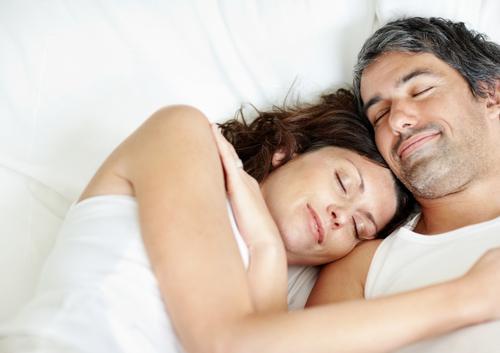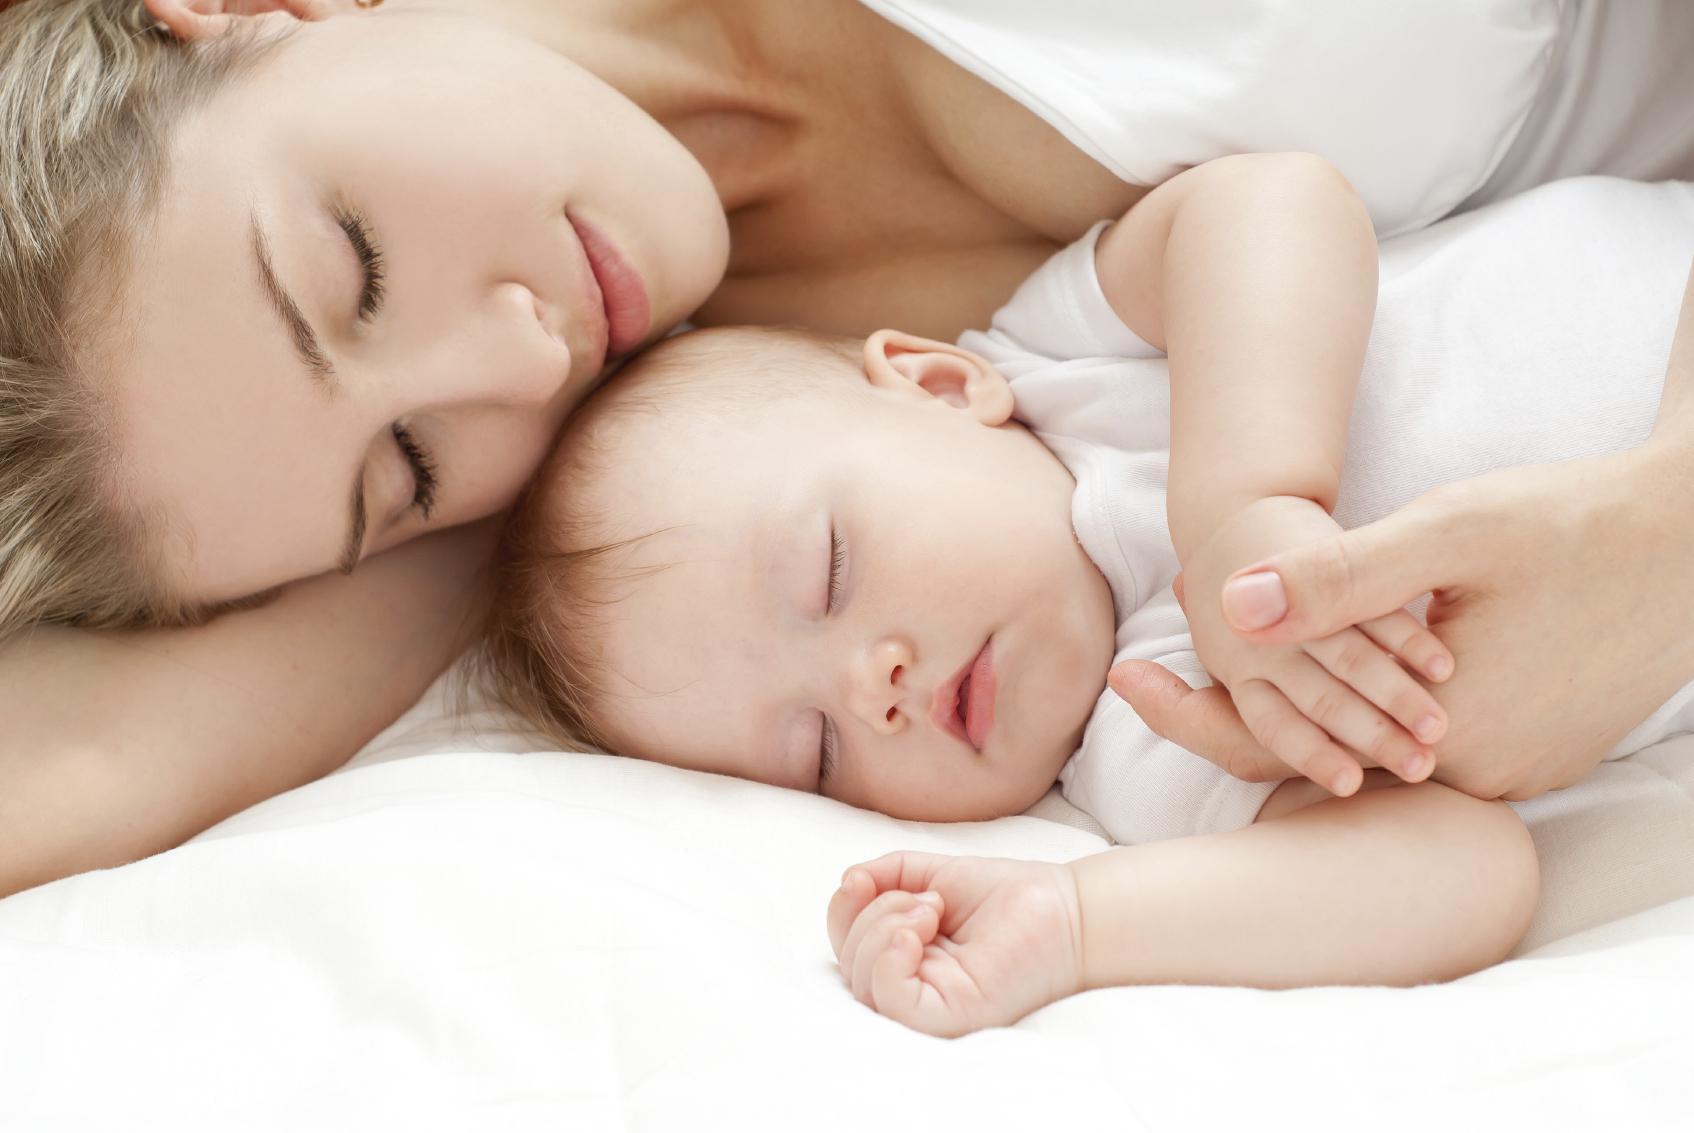The first image is the image on the left, the second image is the image on the right. Examine the images to the left and right. Is the description "A single person is sleeping on a pillow in each of the images." accurate? Answer yes or no. No. 